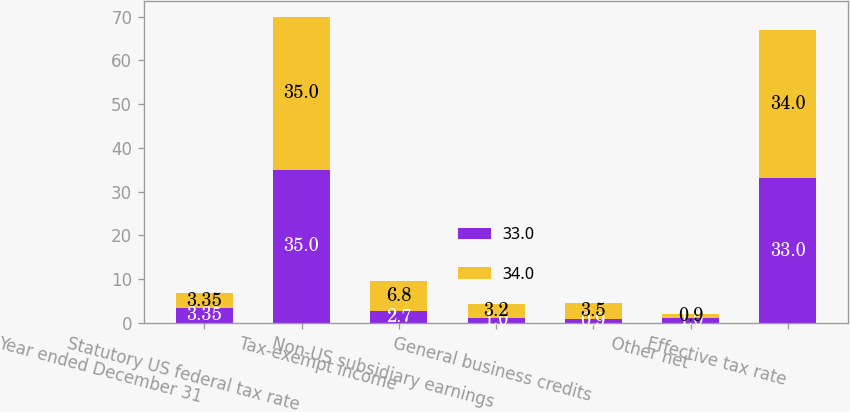Convert chart to OTSL. <chart><loc_0><loc_0><loc_500><loc_500><stacked_bar_chart><ecel><fcel>Year ended December 31<fcel>Statutory US federal tax rate<fcel>Tax-exempt income<fcel>Non-US subsidiary earnings<fcel>General business credits<fcel>Other net<fcel>Effective tax rate<nl><fcel>33<fcel>3.35<fcel>35<fcel>2.7<fcel>1<fcel>0.9<fcel>1<fcel>33<nl><fcel>34<fcel>3.35<fcel>35<fcel>6.8<fcel>3.2<fcel>3.5<fcel>0.9<fcel>34<nl></chart> 